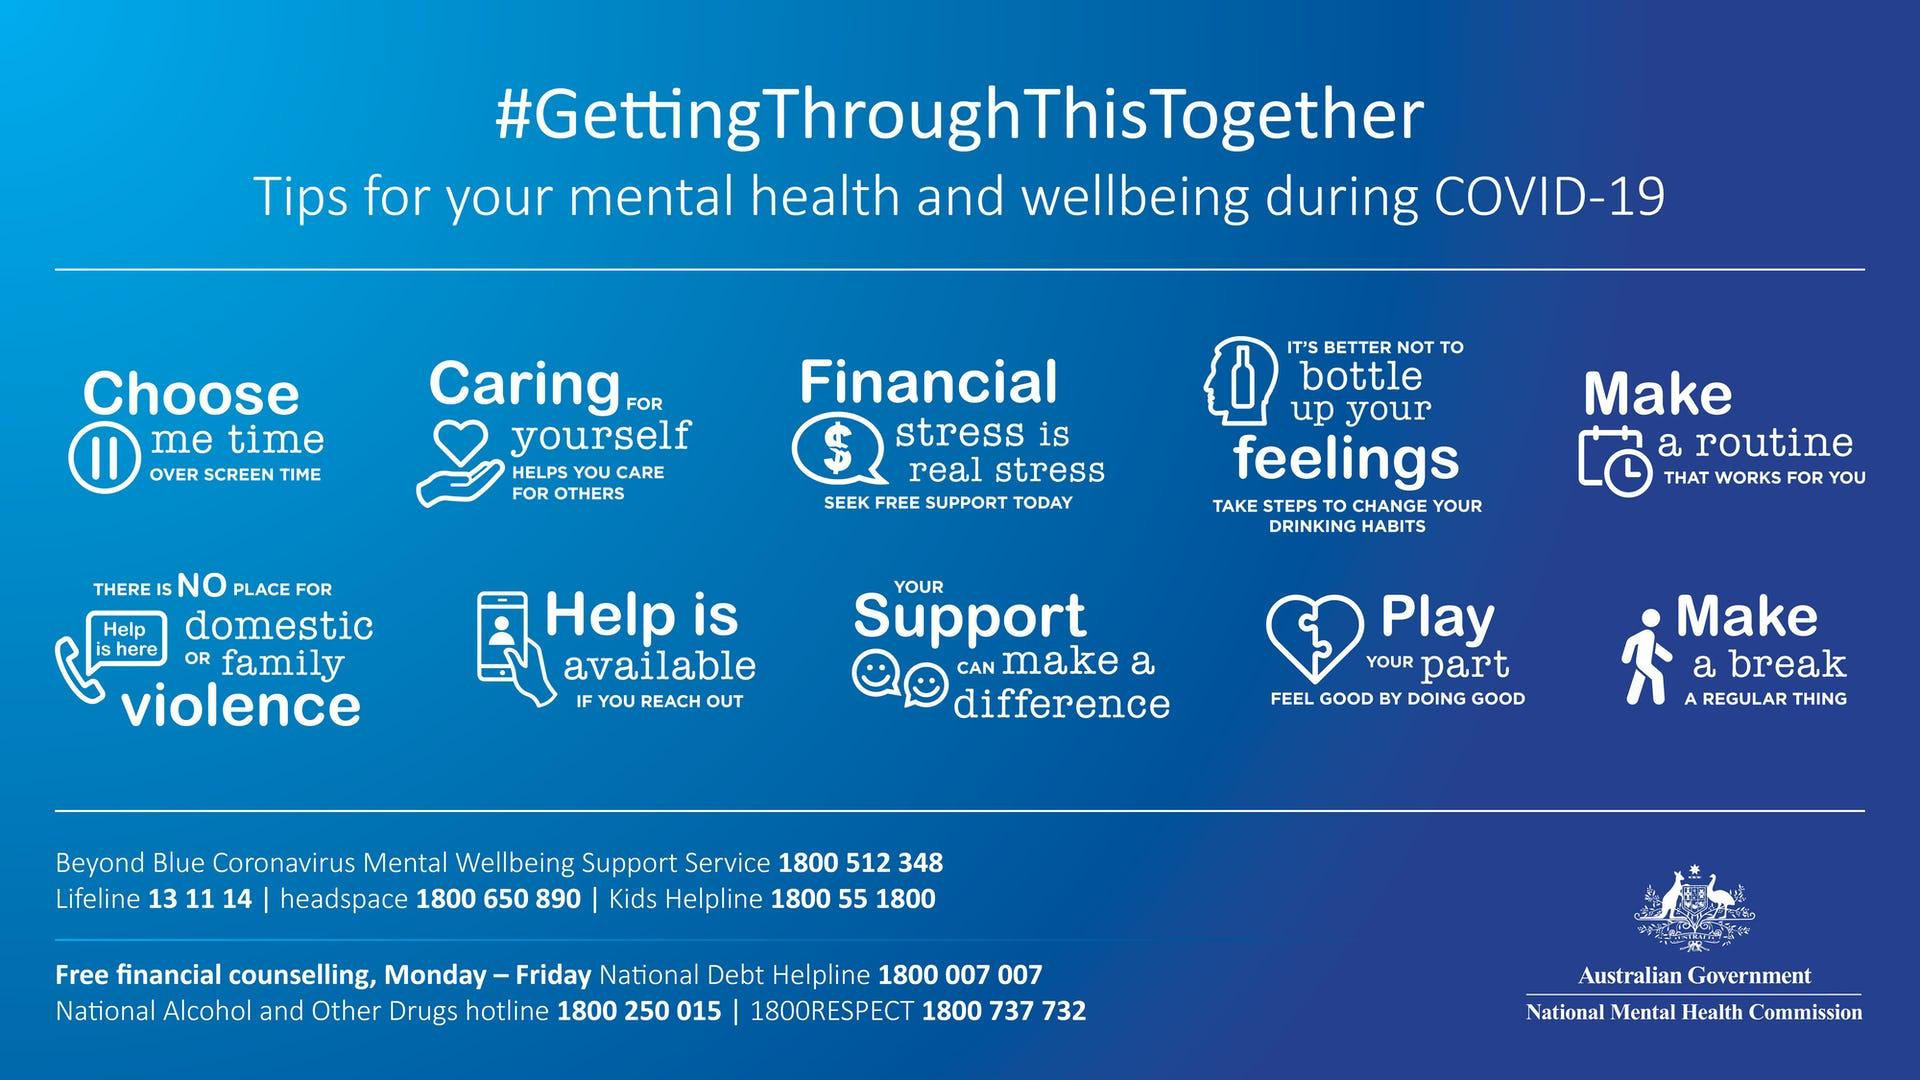Point out several critical features in this image. The sixth tip mentioned in the info graphic is that there is no place for domestic or family violence. The fifth tip mentioned in the info graphic is to create a routine that works for the individual. The information graphic contains ten tips for mental health and well-being in the face of COVID-19. 